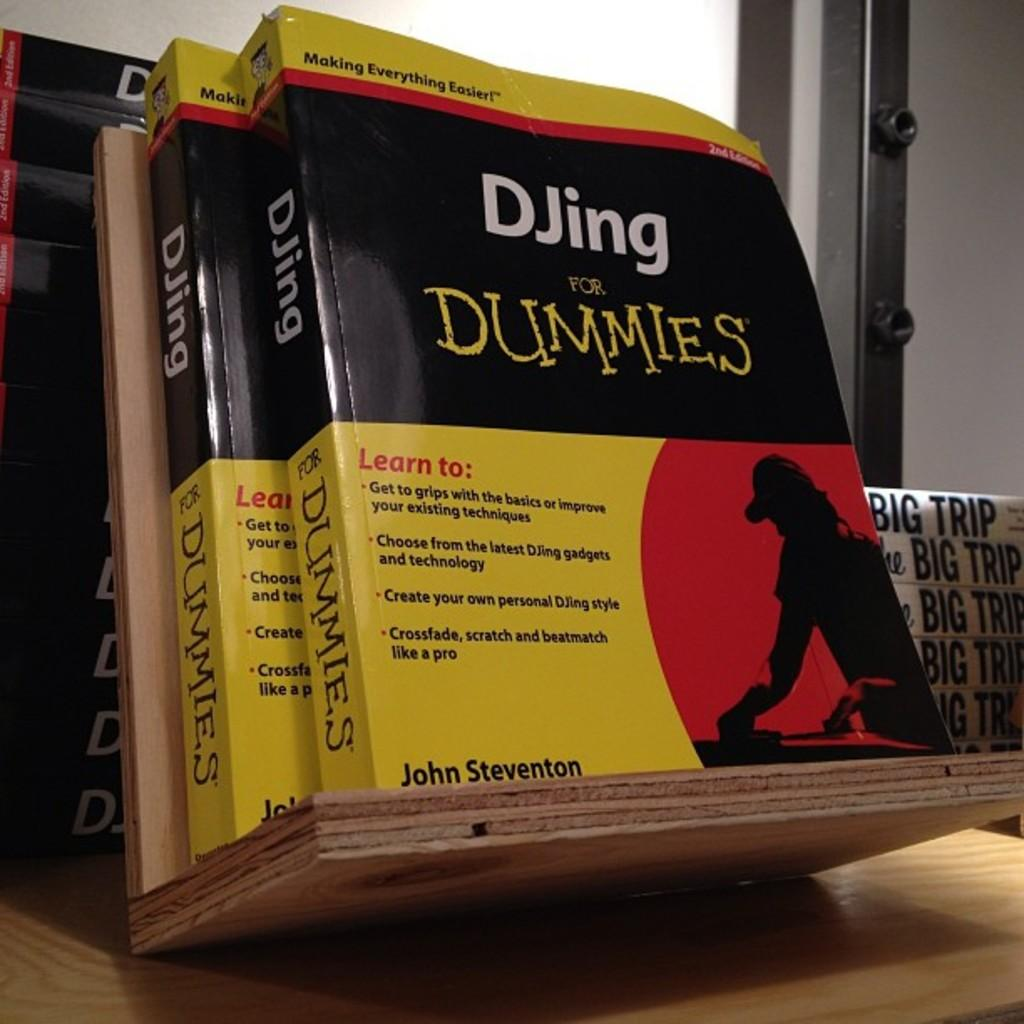<image>
Create a compact narrative representing the image presented. Two books titled 'DJing for dummies' are sitting on a inclined wooden book holder. 